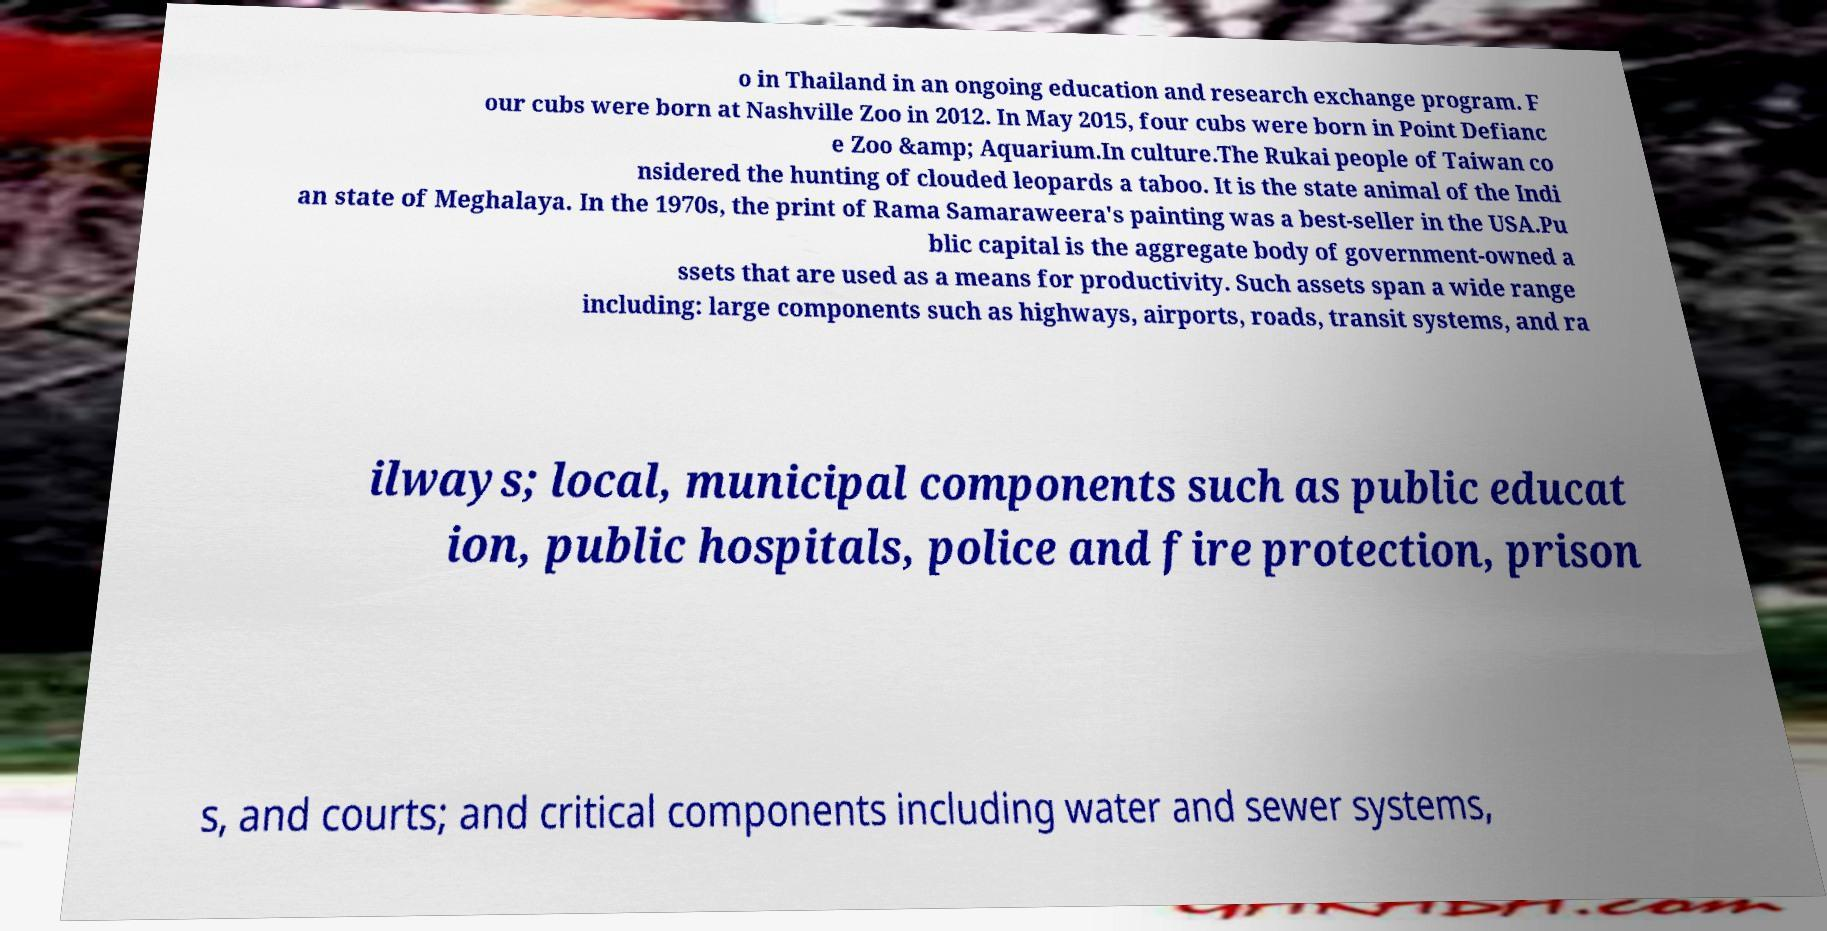Could you extract and type out the text from this image? o in Thailand in an ongoing education and research exchange program. F our cubs were born at Nashville Zoo in 2012. In May 2015, four cubs were born in Point Defianc e Zoo &amp; Aquarium.In culture.The Rukai people of Taiwan co nsidered the hunting of clouded leopards a taboo. It is the state animal of the Indi an state of Meghalaya. In the 1970s, the print of Rama Samaraweera's painting was a best-seller in the USA.Pu blic capital is the aggregate body of government-owned a ssets that are used as a means for productivity. Such assets span a wide range including: large components such as highways, airports, roads, transit systems, and ra ilways; local, municipal components such as public educat ion, public hospitals, police and fire protection, prison s, and courts; and critical components including water and sewer systems, 